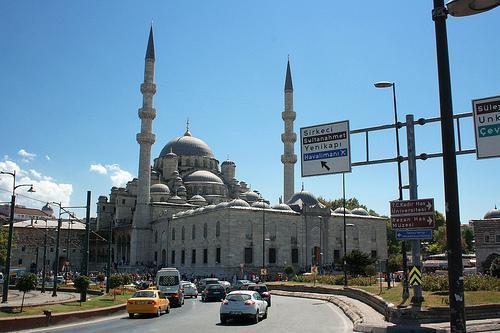How many street signs in this image have white arrows on them?
Give a very brief answer. 2. 